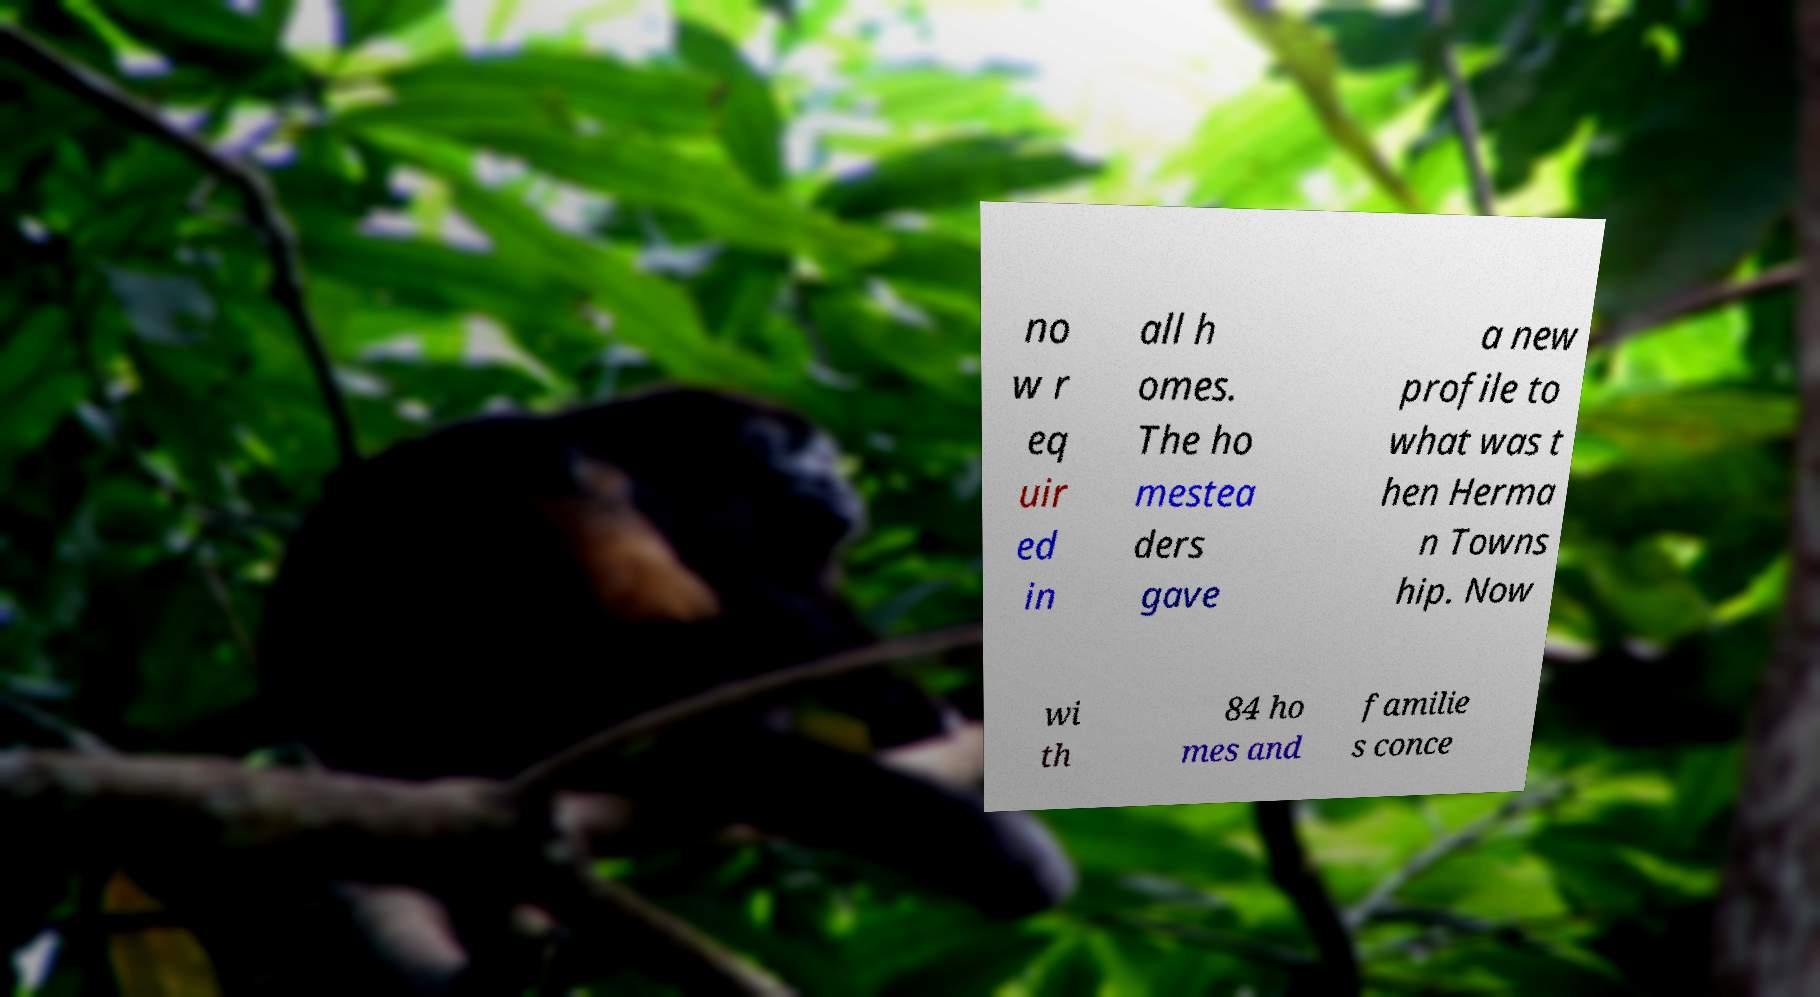For documentation purposes, I need the text within this image transcribed. Could you provide that? no w r eq uir ed in all h omes. The ho mestea ders gave a new profile to what was t hen Herma n Towns hip. Now wi th 84 ho mes and familie s conce 